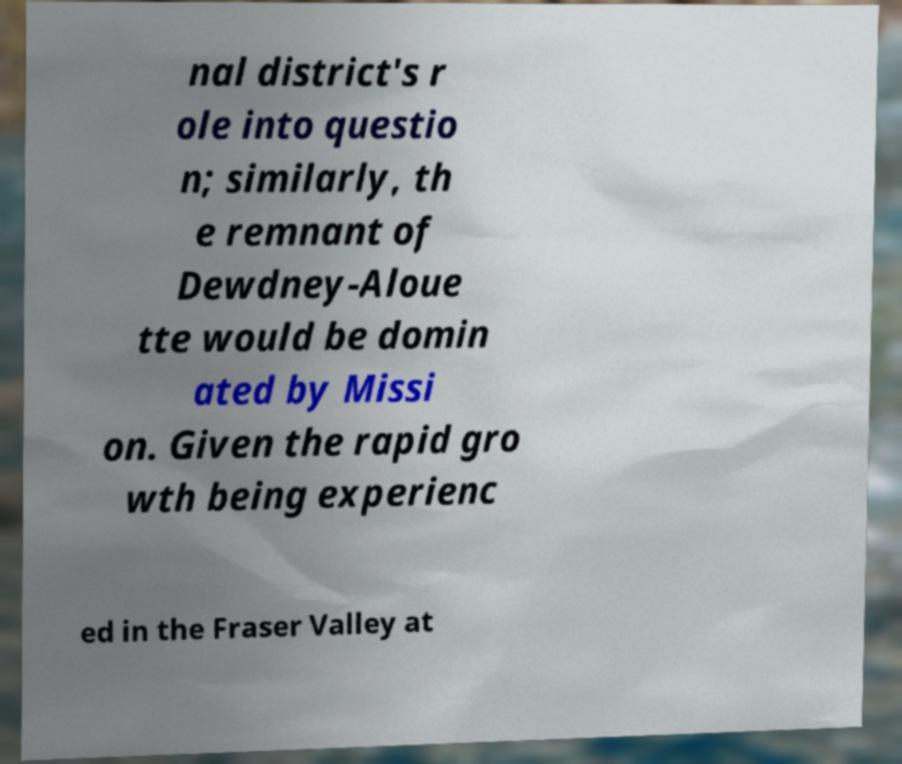Could you assist in decoding the text presented in this image and type it out clearly? nal district's r ole into questio n; similarly, th e remnant of Dewdney-Aloue tte would be domin ated by Missi on. Given the rapid gro wth being experienc ed in the Fraser Valley at 